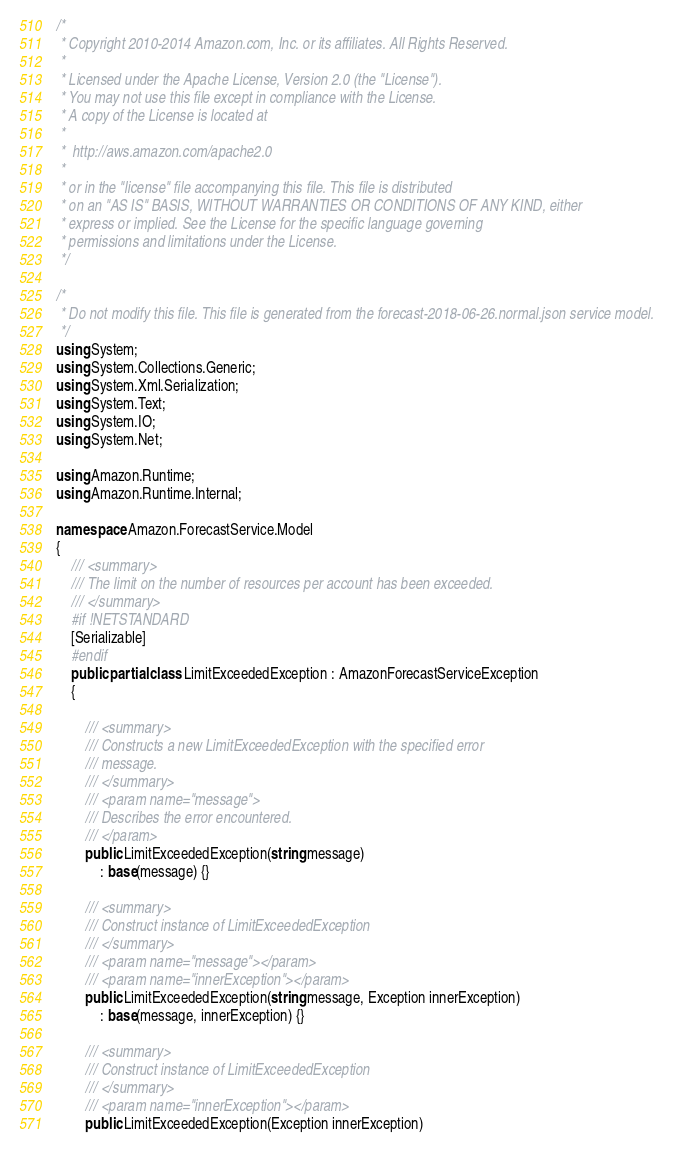<code> <loc_0><loc_0><loc_500><loc_500><_C#_>/*
 * Copyright 2010-2014 Amazon.com, Inc. or its affiliates. All Rights Reserved.
 * 
 * Licensed under the Apache License, Version 2.0 (the "License").
 * You may not use this file except in compliance with the License.
 * A copy of the License is located at
 * 
 *  http://aws.amazon.com/apache2.0
 * 
 * or in the "license" file accompanying this file. This file is distributed
 * on an "AS IS" BASIS, WITHOUT WARRANTIES OR CONDITIONS OF ANY KIND, either
 * express or implied. See the License for the specific language governing
 * permissions and limitations under the License.
 */

/*
 * Do not modify this file. This file is generated from the forecast-2018-06-26.normal.json service model.
 */
using System;
using System.Collections.Generic;
using System.Xml.Serialization;
using System.Text;
using System.IO;
using System.Net;

using Amazon.Runtime;
using Amazon.Runtime.Internal;

namespace Amazon.ForecastService.Model
{
    /// <summary>
    /// The limit on the number of resources per account has been exceeded.
    /// </summary>
    #if !NETSTANDARD
    [Serializable]
    #endif
    public partial class LimitExceededException : AmazonForecastServiceException
    {

        /// <summary>
        /// Constructs a new LimitExceededException with the specified error
        /// message.
        /// </summary>
        /// <param name="message">
        /// Describes the error encountered.
        /// </param>
        public LimitExceededException(string message) 
            : base(message) {}

        /// <summary>
        /// Construct instance of LimitExceededException
        /// </summary>
        /// <param name="message"></param>
        /// <param name="innerException"></param>
        public LimitExceededException(string message, Exception innerException) 
            : base(message, innerException) {}

        /// <summary>
        /// Construct instance of LimitExceededException
        /// </summary>
        /// <param name="innerException"></param>
        public LimitExceededException(Exception innerException) </code> 